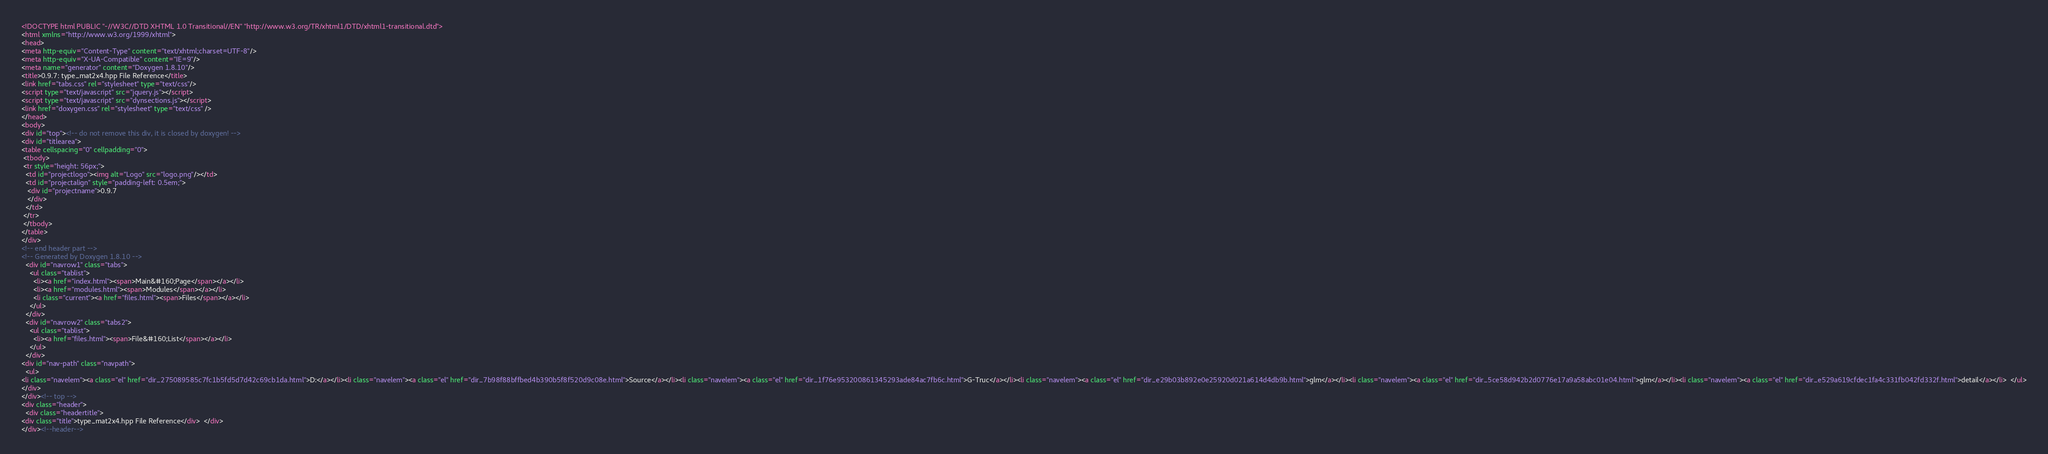<code> <loc_0><loc_0><loc_500><loc_500><_HTML_><!DOCTYPE html PUBLIC "-//W3C//DTD XHTML 1.0 Transitional//EN" "http://www.w3.org/TR/xhtml1/DTD/xhtml1-transitional.dtd">
<html xmlns="http://www.w3.org/1999/xhtml">
<head>
<meta http-equiv="Content-Type" content="text/xhtml;charset=UTF-8"/>
<meta http-equiv="X-UA-Compatible" content="IE=9"/>
<meta name="generator" content="Doxygen 1.8.10"/>
<title>0.9.7: type_mat2x4.hpp File Reference</title>
<link href="tabs.css" rel="stylesheet" type="text/css"/>
<script type="text/javascript" src="jquery.js"></script>
<script type="text/javascript" src="dynsections.js"></script>
<link href="doxygen.css" rel="stylesheet" type="text/css" />
</head>
<body>
<div id="top"><!-- do not remove this div, it is closed by doxygen! -->
<div id="titlearea">
<table cellspacing="0" cellpadding="0">
 <tbody>
 <tr style="height: 56px;">
  <td id="projectlogo"><img alt="Logo" src="logo.png"/></td>
  <td id="projectalign" style="padding-left: 0.5em;">
   <div id="projectname">0.9.7
   </div>
  </td>
 </tr>
 </tbody>
</table>
</div>
<!-- end header part -->
<!-- Generated by Doxygen 1.8.10 -->
  <div id="navrow1" class="tabs">
    <ul class="tablist">
      <li><a href="index.html"><span>Main&#160;Page</span></a></li>
      <li><a href="modules.html"><span>Modules</span></a></li>
      <li class="current"><a href="files.html"><span>Files</span></a></li>
    </ul>
  </div>
  <div id="navrow2" class="tabs2">
    <ul class="tablist">
      <li><a href="files.html"><span>File&#160;List</span></a></li>
    </ul>
  </div>
<div id="nav-path" class="navpath">
  <ul>
<li class="navelem"><a class="el" href="dir_275089585c7fc1b5fd5d7d42c69cb1da.html">D:</a></li><li class="navelem"><a class="el" href="dir_7b98f88bffbed4b390b5f8f520d9c08e.html">Source</a></li><li class="navelem"><a class="el" href="dir_1f76e953200861345293ade84ac7fb6c.html">G-Truc</a></li><li class="navelem"><a class="el" href="dir_e29b03b892e0e25920d021a614d4db9b.html">glm</a></li><li class="navelem"><a class="el" href="dir_5ce58d942b2d0776e17a9a58abc01e04.html">glm</a></li><li class="navelem"><a class="el" href="dir_e529a619cfdec1fa4c331fb042fd332f.html">detail</a></li>  </ul>
</div>
</div><!-- top -->
<div class="header">
  <div class="headertitle">
<div class="title">type_mat2x4.hpp File Reference</div>  </div>
</div><!--header--></code> 